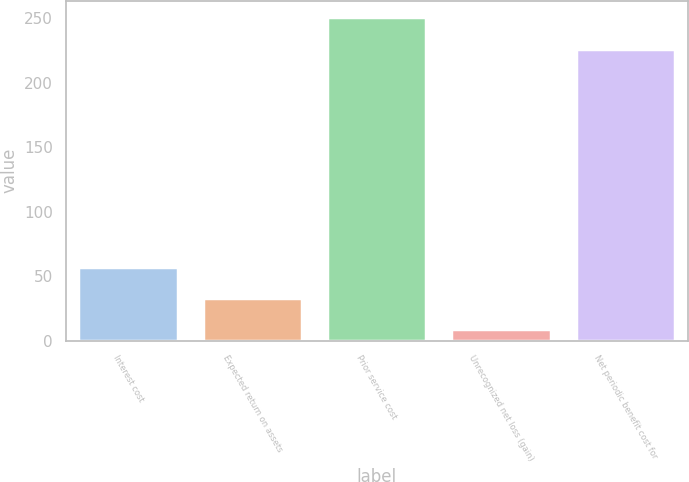Convert chart to OTSL. <chart><loc_0><loc_0><loc_500><loc_500><bar_chart><fcel>Interest cost<fcel>Expected return on assets<fcel>Prior service cost<fcel>Unrecognized net loss (gain)<fcel>Net periodic benefit cost for<nl><fcel>57.4<fcel>33.2<fcel>251<fcel>9<fcel>226<nl></chart> 